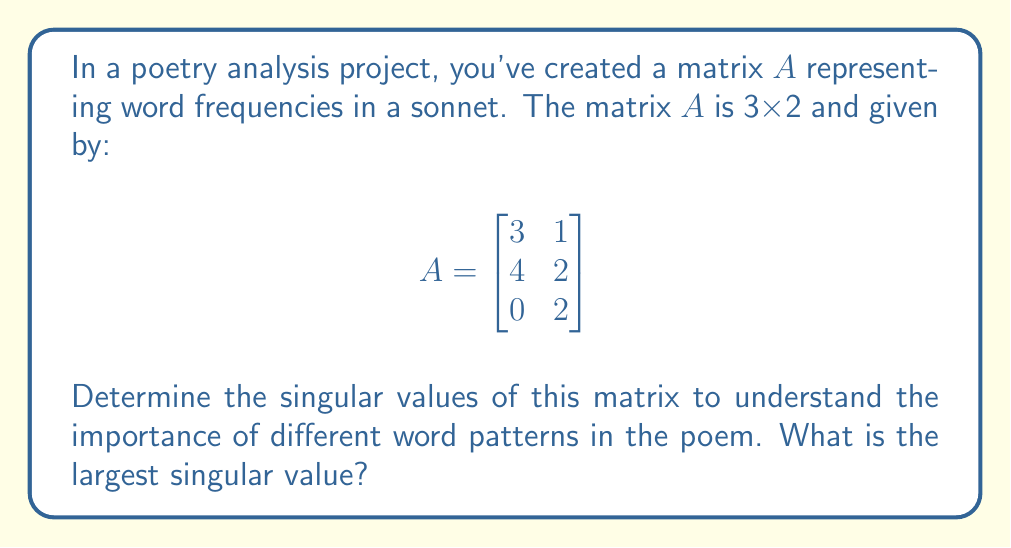What is the answer to this math problem? To find the singular values of matrix $A$, we need to follow these steps:

1) First, calculate $A^TA$:
   $$A^TA = \begin{bmatrix}
   3 & 4 & 0 \\
   1 & 2 & 2
   \end{bmatrix} \begin{bmatrix}
   3 & 1 \\
   4 & 2 \\
   0 & 2
   \end{bmatrix} = \begin{bmatrix}
   25 & 11 \\
   11 & 9
   \end{bmatrix}$$

2) Find the eigenvalues of $A^TA$ by solving the characteristic equation:
   $$\det(A^TA - \lambda I) = \begin{vmatrix}
   25-\lambda & 11 \\
   11 & 9-\lambda
   \end{vmatrix} = (25-\lambda)(9-\lambda) - 121 = \lambda^2 - 34\lambda + 104 = 0$$

3) Solve this quadratic equation:
   $\lambda = \frac{34 \pm \sqrt{34^2 - 4(104)}}{2} = \frac{34 \pm \sqrt{852}}{2}$

4) The eigenvalues are:
   $\lambda_1 = \frac{34 + \sqrt{852}}{2} \approx 31.61$
   $\lambda_2 = \frac{34 - \sqrt{852}}{2} \approx 2.39$

5) The singular values are the square roots of these eigenvalues:
   $\sigma_1 = \sqrt{\lambda_1} \approx \sqrt{31.61} \approx 5.62$
   $\sigma_2 = \sqrt{\lambda_2} \approx \sqrt{2.39} \approx 1.55$

The largest singular value is $\sigma_1 \approx 5.62$.
Answer: $5.62$ (rounded to two decimal places) 